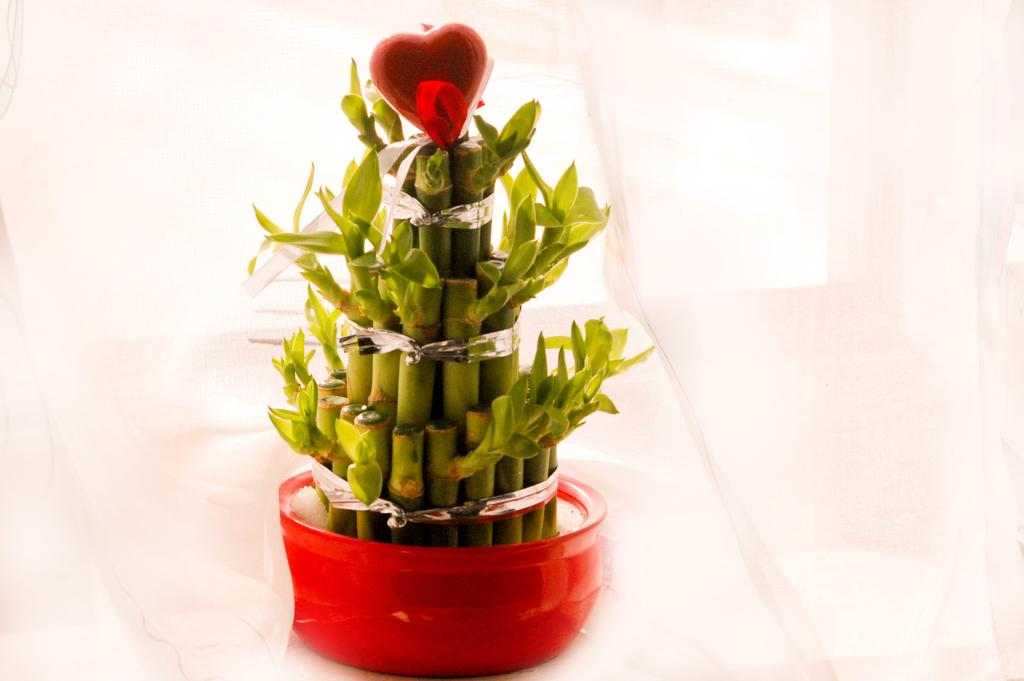What is located in the middle of the image? There is a flower pot with plants in the image. What is the color of the background in the image? The background of the image is white. What type of insect can be seen on the plants in the image? There are no insects visible on the plants in the image. 